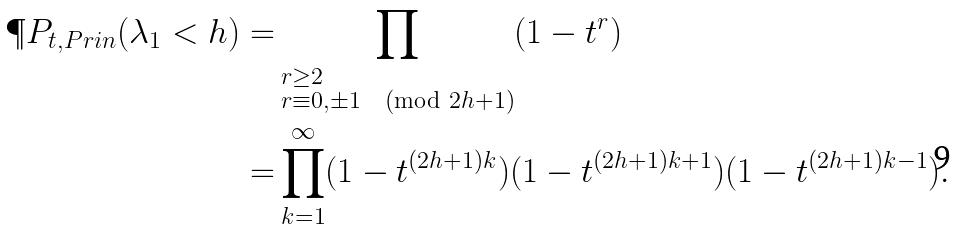Convert formula to latex. <formula><loc_0><loc_0><loc_500><loc_500>\P P _ { t , P r i n } ( \lambda _ { 1 } < h ) = & \prod _ { \begin{subarray} { c } r \geq 2 \\ r \equiv 0 , \pm 1 \pmod { 2 h + 1 } \end{subarray} } ( 1 - t ^ { r } ) \\ = & \prod _ { k = 1 } ^ { \infty } ( 1 - t ^ { ( 2 h + 1 ) k } ) ( 1 - t ^ { ( 2 h + 1 ) k + 1 } ) ( 1 - t ^ { ( 2 h + 1 ) k - 1 } ) .</formula> 